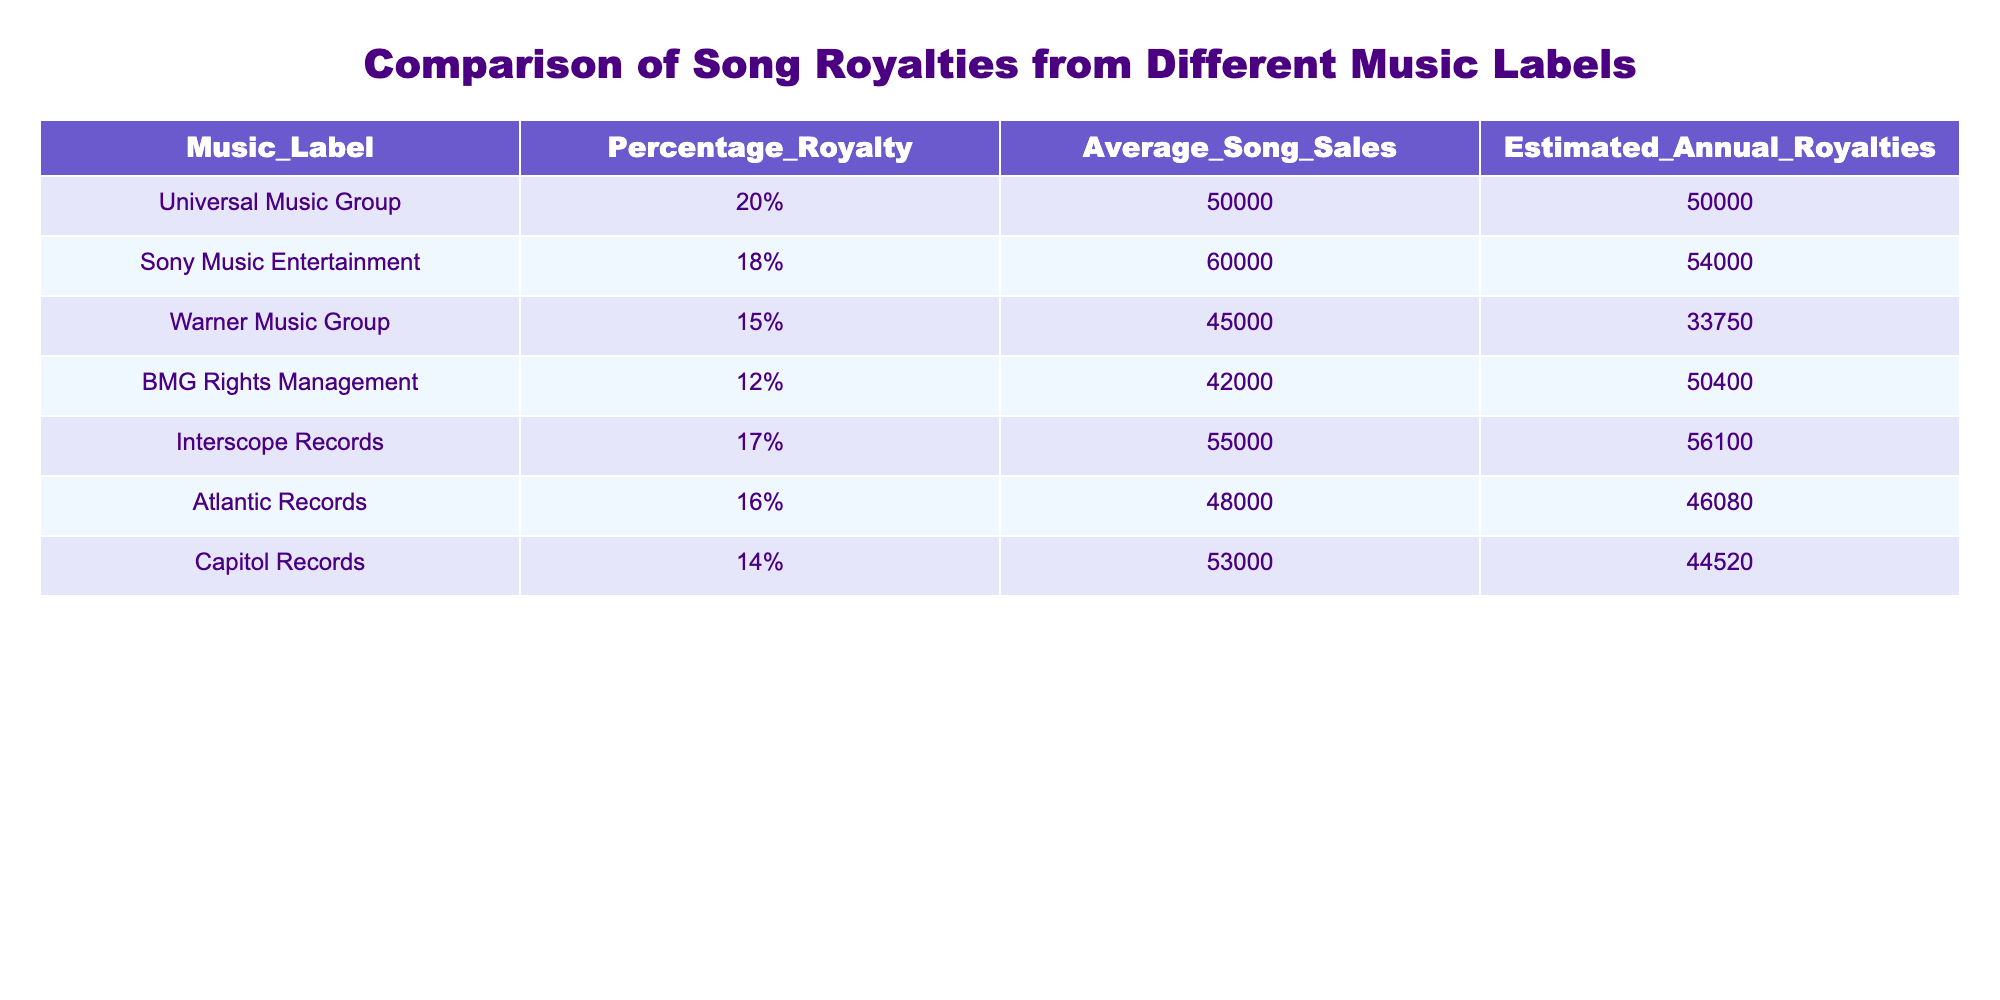What is the highest estimated annual royalty among the music labels? From the table, the estimated annual royalties for each music label are as follows: Universal Music Group (50000), Sony Music Entertainment (54000), Warner Music Group (33750), BMG Rights Management (50400), Interscope Records (56100), Atlantic Records (46080), and Capitol Records (44520). The highest value is 56100, from Interscope Records.
Answer: 56100 Which music label has the lowest percentage royalty? Looking at the Percentage Royalty column, the values are: Universal Music Group (20%), Sony Music Entertainment (18%), Warner Music Group (15%), BMG Rights Management (12%), Interscope Records (17%), Atlantic Records (16%), and Capitol Records (14%). The lowest percentage is 12%, from BMG Rights Management.
Answer: BMG Rights Management What is the total estimated annual royalty of the top three music labels by estimated annual royalties? From the table, the estimated annual royalties for the top three music labels are: Interscope Records (56100), Sony Music Entertainment (54000), and BMG Rights Management (50400). Summing these values gives 56100 + 54000 + 50400 = 160500.
Answer: 160500 Is the average song sales higher for Warner Music Group than for Capitol Records? The average song sales for Warner Music Group is 45000 and for Capitol Records is 53000. Since 45000 is less than 53000, Warner Music Group does not have higher average song sales.
Answer: No What is the difference in estimated annual royalties between Universal Music Group and Warner Music Group? The estimated annual royalties for Universal Music Group is 50000 and for Warner Music Group is 33750. The difference can be calculated as 50000 - 33750 = 16250.
Answer: 16250 Which music label has a higher average song sales, BMG Rights Management or Atlantic Records? The average song sales for BMG Rights Management is 42000 and for Atlantic Records is 48000. Since 48000 is greater than 42000, Atlantic Records has the higher average song sales.
Answer: Atlantic Records How many music labels have a percentage royalty of 15% or higher? Examining the Percentage Royalty column, the labels with percentage royalties of 15% or higher are: Universal Music Group (20%), Sony Music Entertainment (18%), Interscope Records (17%), Atlantic Records (16%), and Capitol Records (14%). This counts to five labels.
Answer: 5 What is the average percentage royalty across all music labels? The percentage royalties are: 20%, 18%, 15%, 12%, 17%, 16%, and 14%. To calculate the average, first sum these values: (20 + 18 + 15 + 12 + 17 + 16 + 14) = 112. There are 7 music labels, so the average is 112 / 7 = 16. This rounds to 16%.
Answer: 16% 